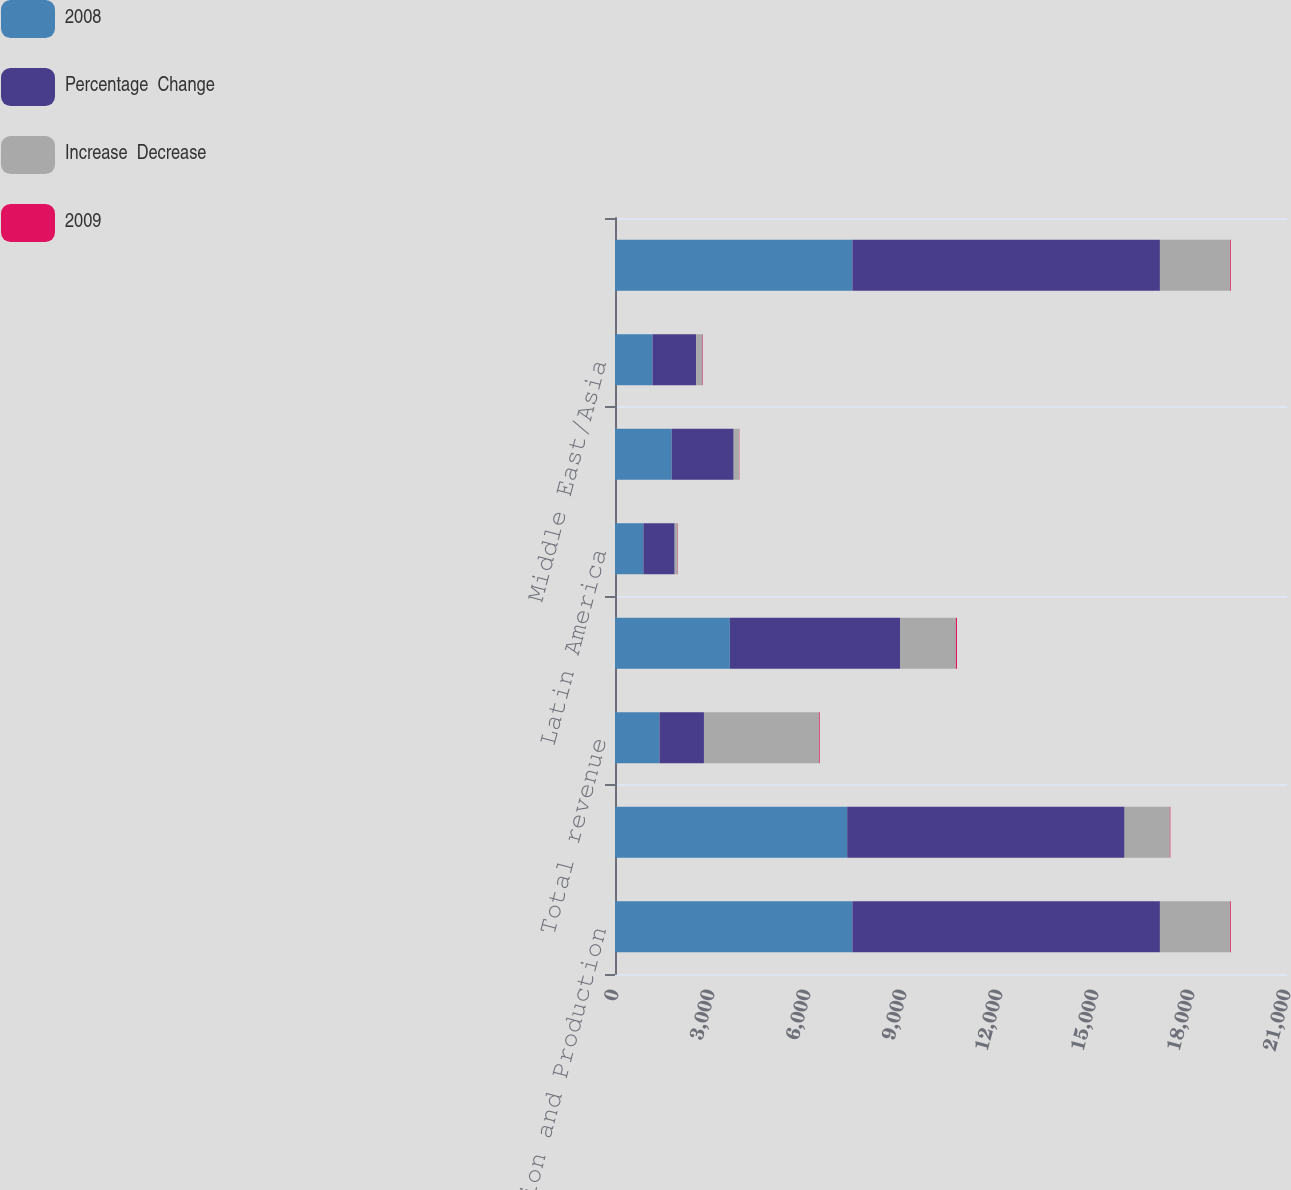Convert chart. <chart><loc_0><loc_0><loc_500><loc_500><stacked_bar_chart><ecel><fcel>Completion and Production<fcel>Drilling and Evaluation<fcel>Total revenue<fcel>North America<fcel>Latin America<fcel>Europe/Africa/CIS<fcel>Middle East/Asia<fcel>Total<nl><fcel>2008<fcel>7419<fcel>7256<fcel>1390<fcel>3589<fcel>887<fcel>1771<fcel>1172<fcel>7419<nl><fcel>Percentage  Change<fcel>9610<fcel>8669<fcel>1390<fcel>5327<fcel>978<fcel>1938<fcel>1367<fcel>9610<nl><fcel>Increase  Decrease<fcel>2191<fcel>1413<fcel>3604<fcel>1738<fcel>91<fcel>167<fcel>195<fcel>2191<nl><fcel>2009<fcel>23<fcel>16<fcel>20<fcel>33<fcel>9<fcel>9<fcel>14<fcel>23<nl></chart> 